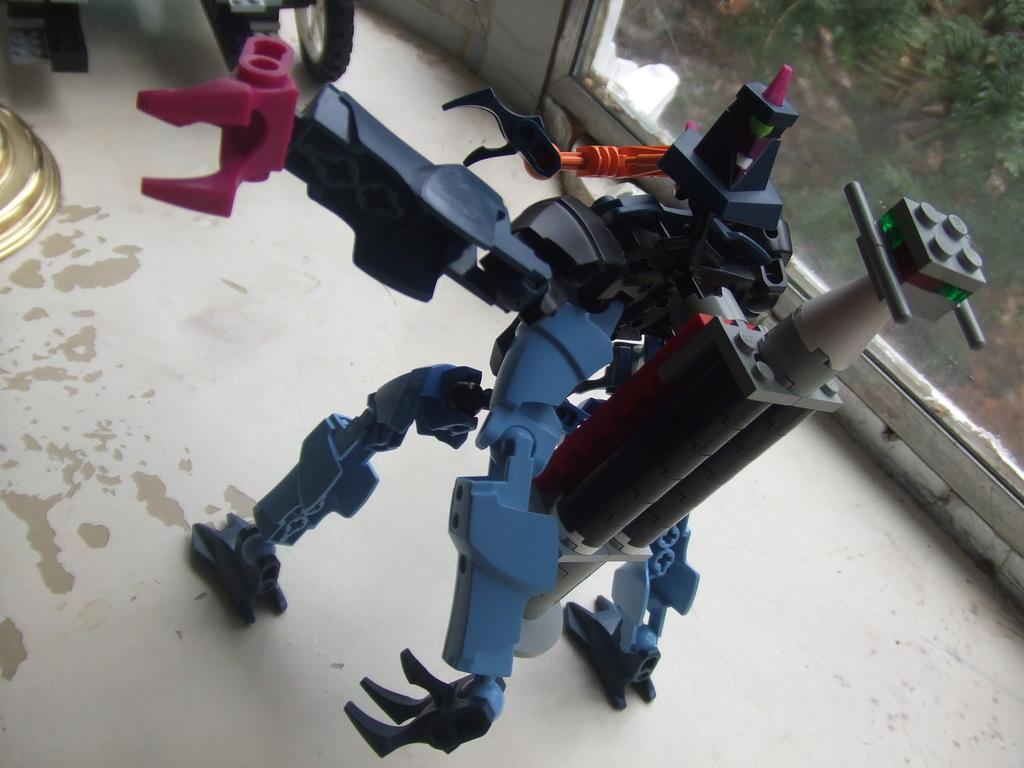What is on the floor in the image? There is a toy on the floor. What can be seen in the background of the image? There is a glass in the background. What is visible through the glass? Plants are visible through the glass. What statement is being made by the toy in the image? The toy in the image is not making any statements, as it is an inanimate object. 